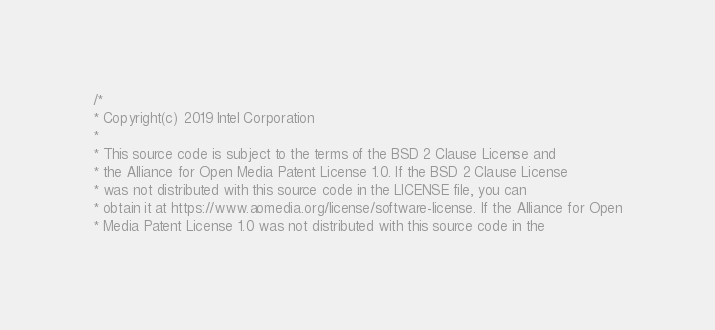Convert code to text. <code><loc_0><loc_0><loc_500><loc_500><_C_>/*
* Copyright(c) 2019 Intel Corporation
*
* This source code is subject to the terms of the BSD 2 Clause License and
* the Alliance for Open Media Patent License 1.0. If the BSD 2 Clause License
* was not distributed with this source code in the LICENSE file, you can
* obtain it at https://www.aomedia.org/license/software-license. If the Alliance for Open
* Media Patent License 1.0 was not distributed with this source code in the</code> 